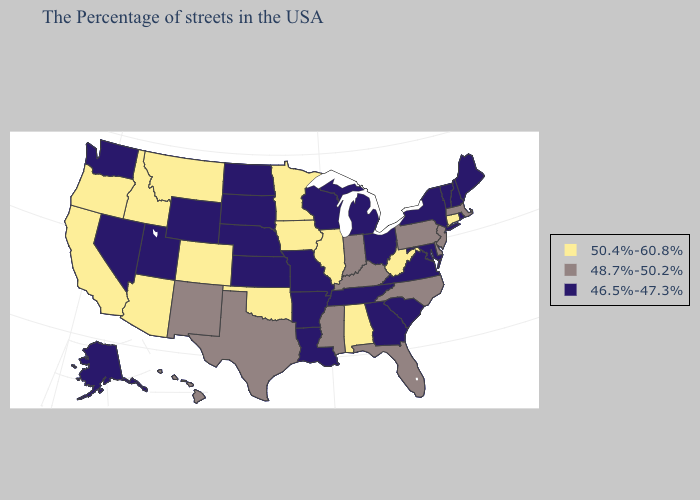Name the states that have a value in the range 48.7%-50.2%?
Concise answer only. Massachusetts, New Jersey, Delaware, Pennsylvania, North Carolina, Florida, Kentucky, Indiana, Mississippi, Texas, New Mexico, Hawaii. Name the states that have a value in the range 50.4%-60.8%?
Short answer required. Connecticut, West Virginia, Alabama, Illinois, Minnesota, Iowa, Oklahoma, Colorado, Montana, Arizona, Idaho, California, Oregon. Does Indiana have the lowest value in the MidWest?
Be succinct. No. What is the value of Minnesota?
Answer briefly. 50.4%-60.8%. Which states have the lowest value in the USA?
Quick response, please. Maine, Rhode Island, New Hampshire, Vermont, New York, Maryland, Virginia, South Carolina, Ohio, Georgia, Michigan, Tennessee, Wisconsin, Louisiana, Missouri, Arkansas, Kansas, Nebraska, South Dakota, North Dakota, Wyoming, Utah, Nevada, Washington, Alaska. Which states have the lowest value in the USA?
Quick response, please. Maine, Rhode Island, New Hampshire, Vermont, New York, Maryland, Virginia, South Carolina, Ohio, Georgia, Michigan, Tennessee, Wisconsin, Louisiana, Missouri, Arkansas, Kansas, Nebraska, South Dakota, North Dakota, Wyoming, Utah, Nevada, Washington, Alaska. What is the value of Alaska?
Be succinct. 46.5%-47.3%. Name the states that have a value in the range 50.4%-60.8%?
Give a very brief answer. Connecticut, West Virginia, Alabama, Illinois, Minnesota, Iowa, Oklahoma, Colorado, Montana, Arizona, Idaho, California, Oregon. Among the states that border Wyoming , does Montana have the highest value?
Write a very short answer. Yes. Name the states that have a value in the range 46.5%-47.3%?
Answer briefly. Maine, Rhode Island, New Hampshire, Vermont, New York, Maryland, Virginia, South Carolina, Ohio, Georgia, Michigan, Tennessee, Wisconsin, Louisiana, Missouri, Arkansas, Kansas, Nebraska, South Dakota, North Dakota, Wyoming, Utah, Nevada, Washington, Alaska. What is the lowest value in the USA?
Keep it brief. 46.5%-47.3%. What is the lowest value in the USA?
Give a very brief answer. 46.5%-47.3%. Name the states that have a value in the range 48.7%-50.2%?
Write a very short answer. Massachusetts, New Jersey, Delaware, Pennsylvania, North Carolina, Florida, Kentucky, Indiana, Mississippi, Texas, New Mexico, Hawaii. 